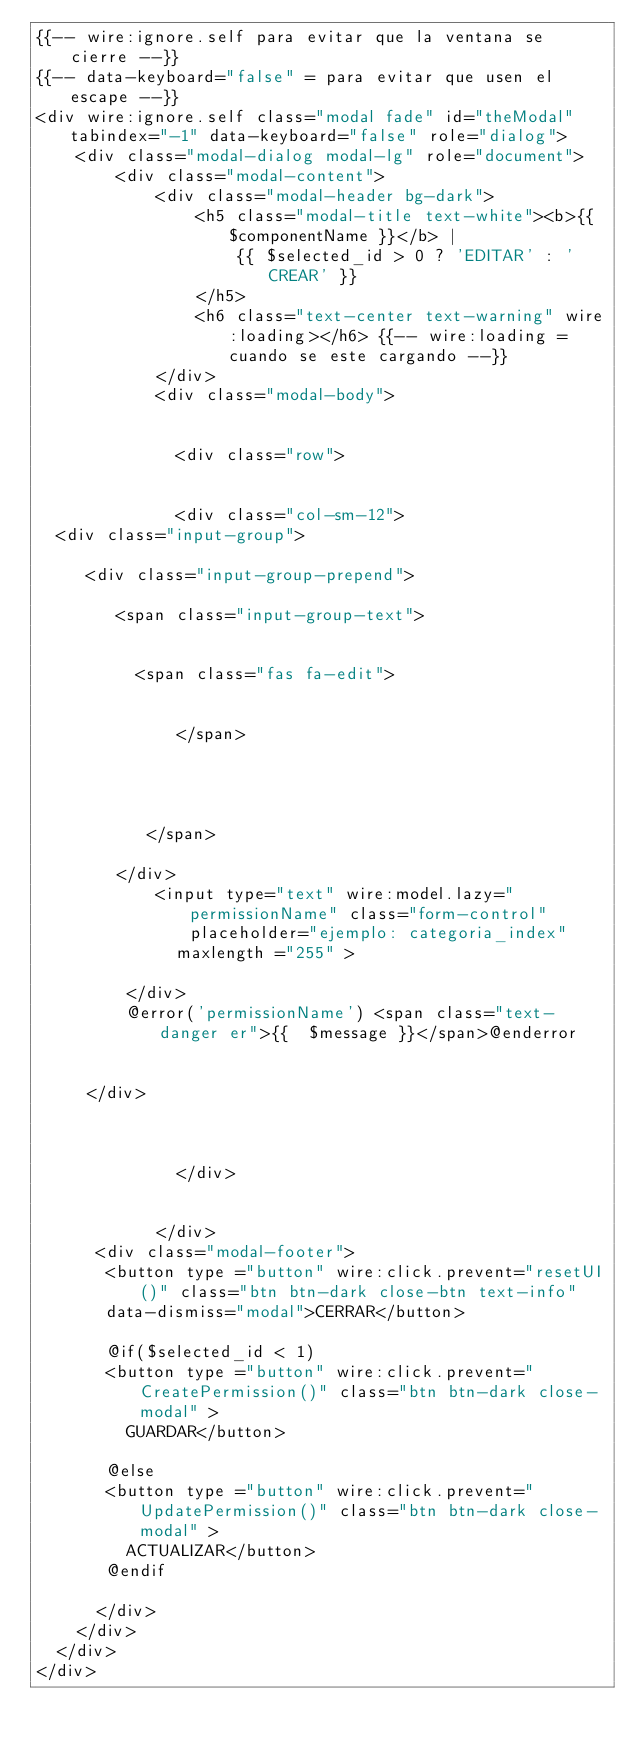Convert code to text. <code><loc_0><loc_0><loc_500><loc_500><_PHP_>{{-- wire:ignore.self para evitar que la ventana se cierre --}}
{{-- data-keyboard="false" = para evitar que usen el escape --}}
<div wire:ignore.self class="modal fade" id="theModal" tabindex="-1" data-keyboard="false" role="dialog">
    <div class="modal-dialog modal-lg" role="document">
        <div class="modal-content">
            <div class="modal-header bg-dark">
                <h5 class="modal-title text-white"><b>{{ $componentName }}</b> |
                    {{ $selected_id > 0 ? 'EDITAR' : 'CREAR' }}
                </h5>
                <h6 class="text-center text-warning" wire:loading></h6> {{-- wire:loading = cuando se este cargando --}}
            </div>
            <div class="modal-body">

             
              <div class="row">


              <div class="col-sm-12">
  <div class="input-group">

     <div class="input-group-prepend">

        <span class="input-group-text">
    

          <span class="fas fa-edit">


              </span>




           </span>

        </div>
            <input type="text" wire:model.lazy="permissionName" class="form-control" placeholder="ejemplo: categoria_index"
              maxlength ="255" >

         </div>
         @error('permissionName') <span class="text-danger er">{{  $message }}</span>@enderror


     </div>
                   


              </div>


            </div>
      <div class="modal-footer">
       <button type ="button" wire:click.prevent="resetUI()" class="btn btn-dark close-btn text-info" 
       data-dismiss="modal">CERRAR</button>
       
       @if($selected_id < 1)
       <button type ="button" wire:click.prevent="CreatePermission()" class="btn btn-dark close-modal" >
         GUARDAR</button>
    
       @else
       <button type ="button" wire:click.prevent="UpdatePermission()" class="btn btn-dark close-modal" >
         ACTUALIZAR</button>
       @endif

      </div>
    </div>
  </div>
</div></code> 